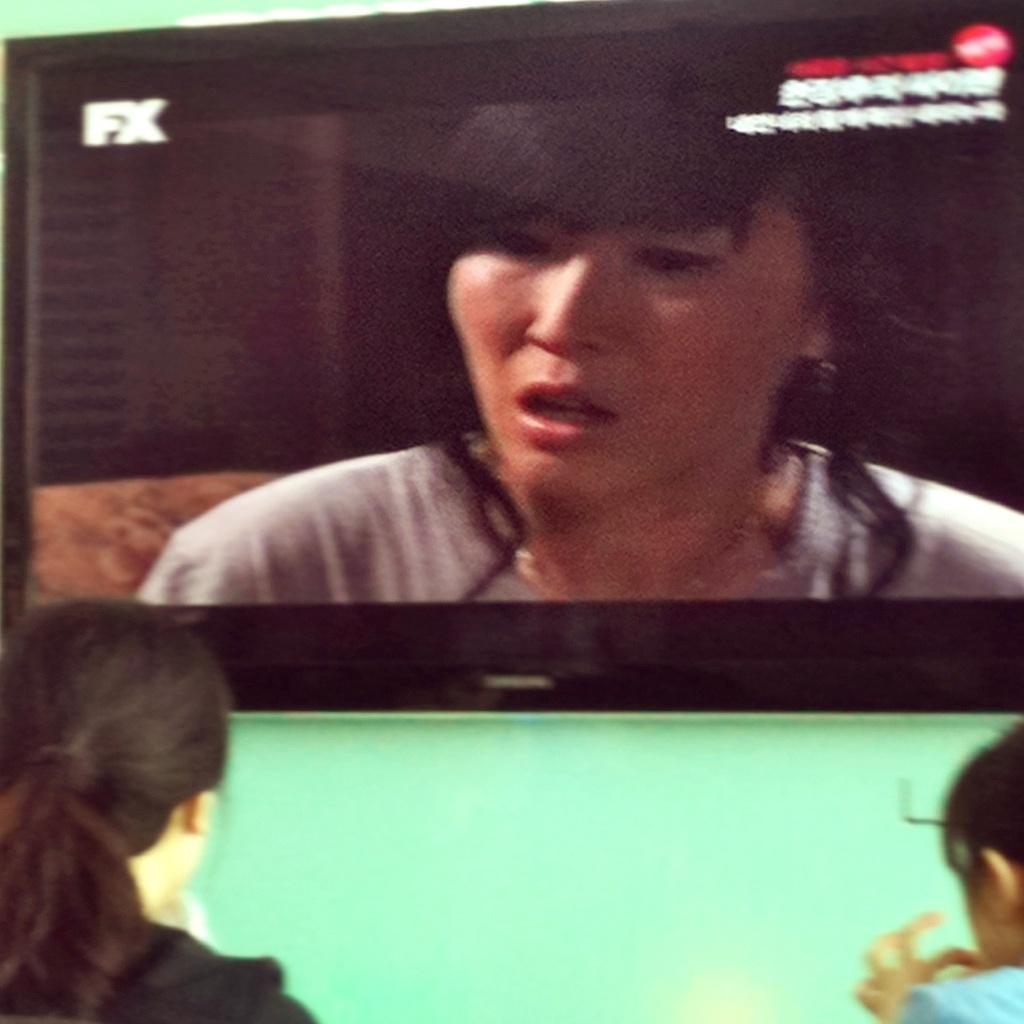Describe this image in one or two sentences. In this image we can see few people. We can see a television on the wall. On the television screen we can see a lady and some text. 